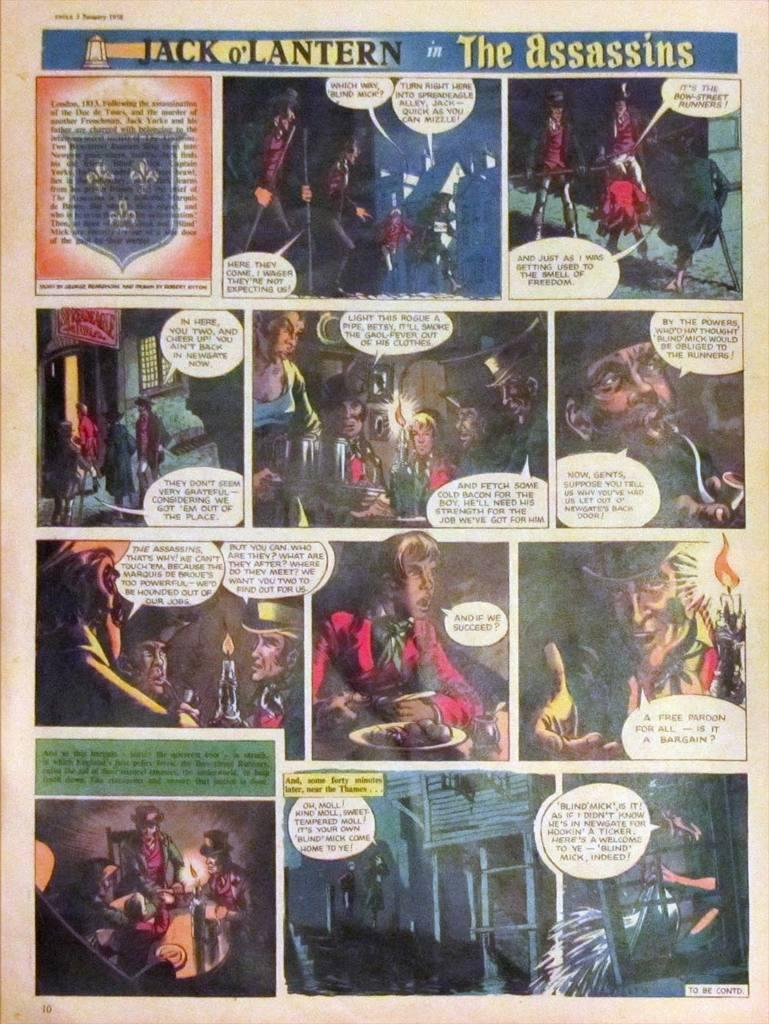<image>
Describe the image concisely. A comic book page of Jack o' Lantern in the Assassins. 